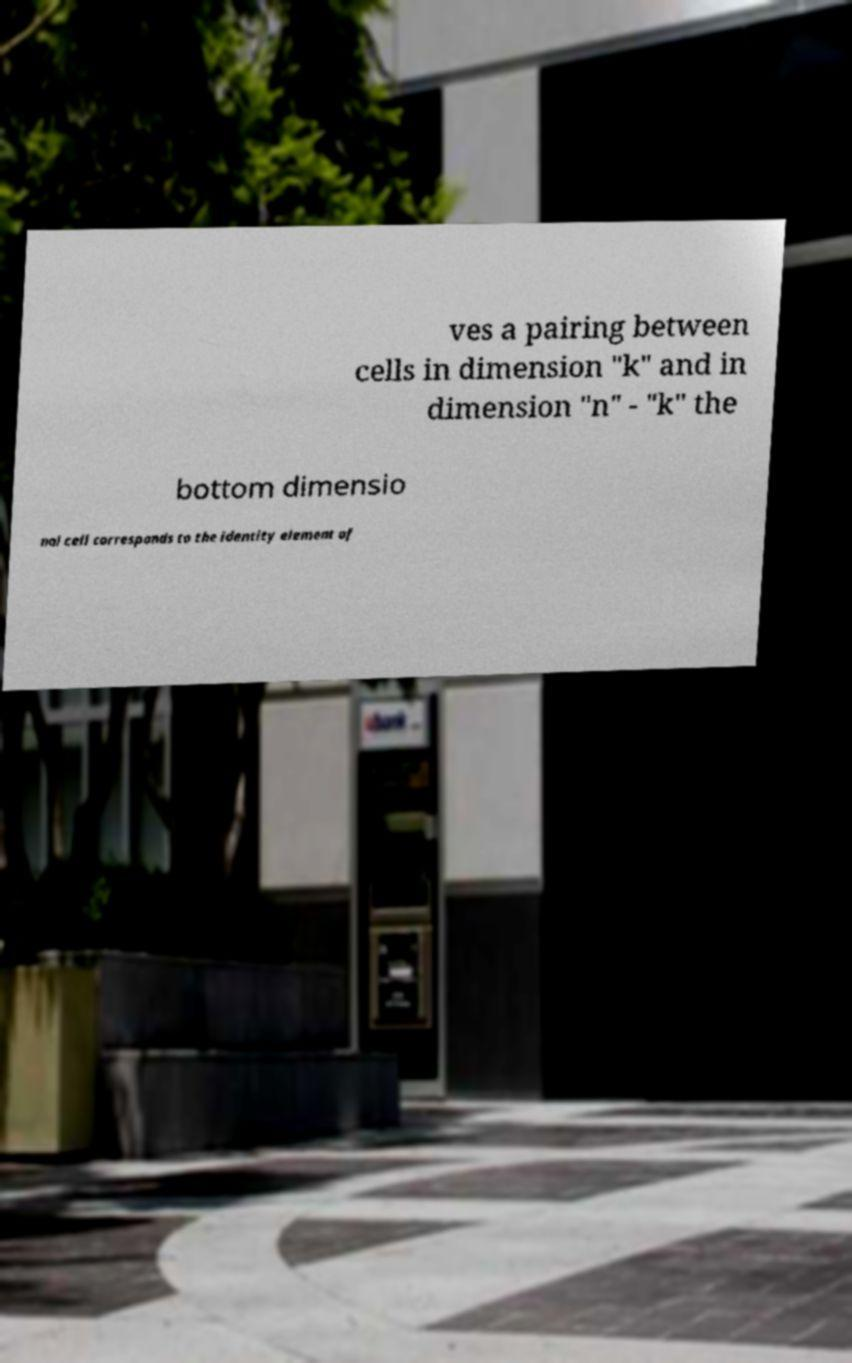What messages or text are displayed in this image? I need them in a readable, typed format. ves a pairing between cells in dimension "k" and in dimension "n" - "k" the bottom dimensio nal cell corresponds to the identity element of 